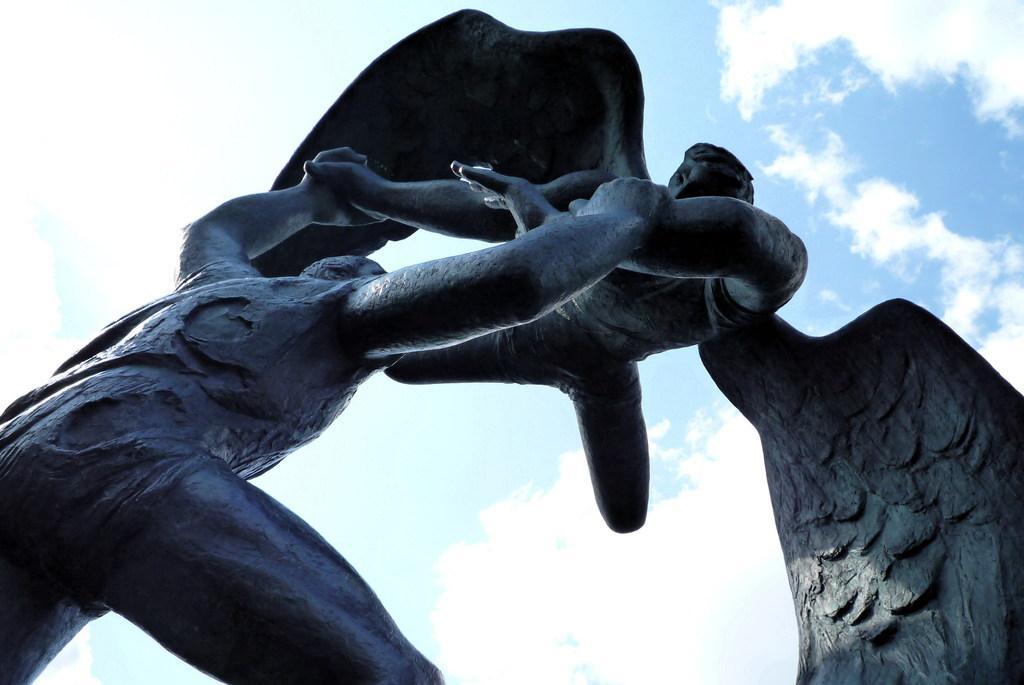Could you give a brief overview of what you see in this image? There is a statue of a person holding another person who has wings and the sky is a bit cloudy. 